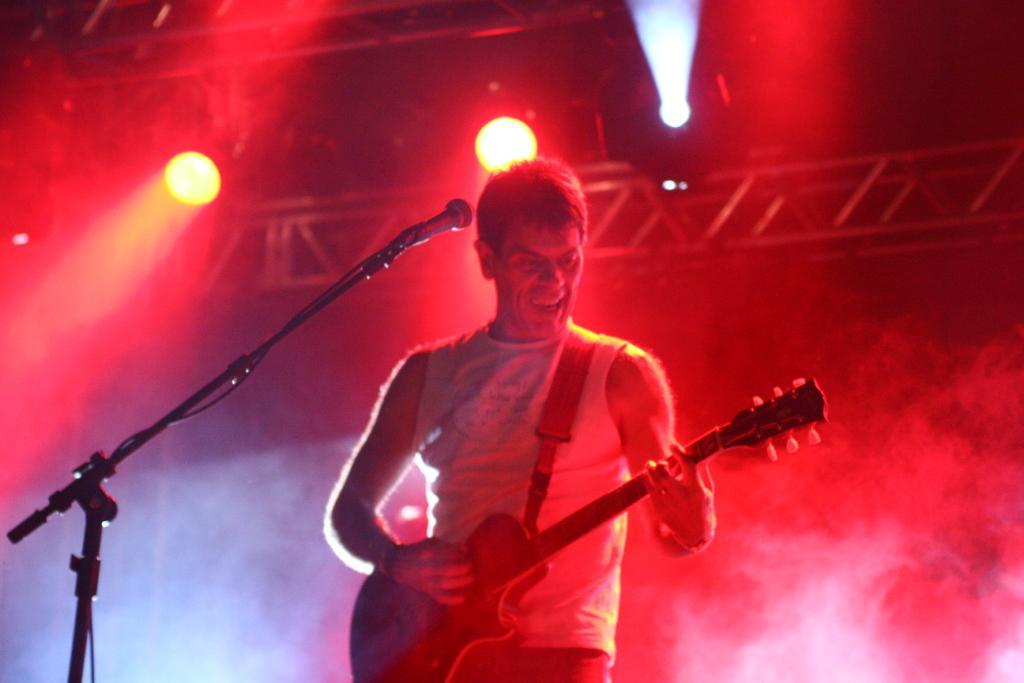Please provide a concise description of this image. In this image we can see a man holding a musical instrument and a mic is placed in front of him. In the background we can see electric lights and an iron grill. 